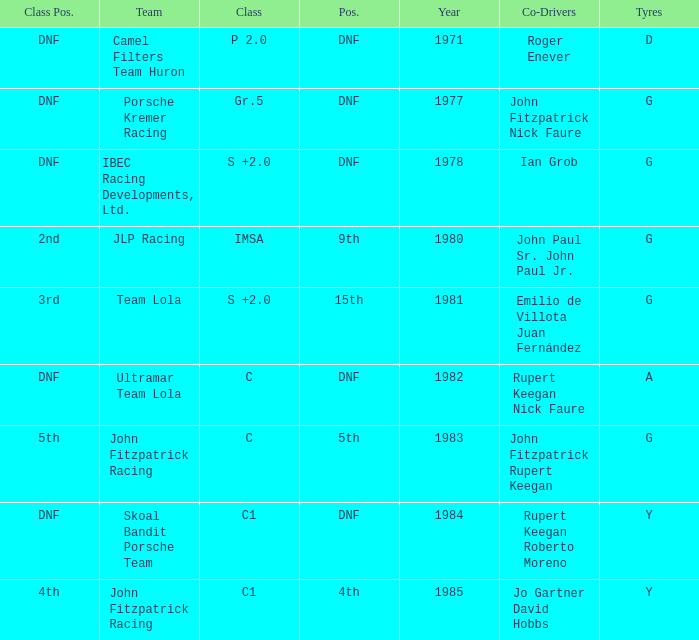Which tires were in Class C in years before 1983? A. 